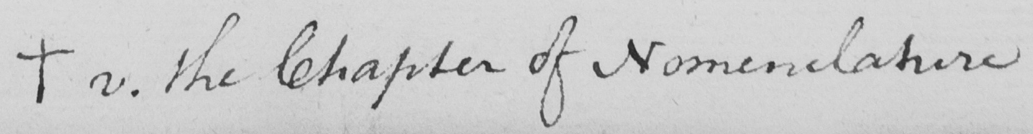Can you tell me what this handwritten text says? +  v . the Chapter of Nomenclature 